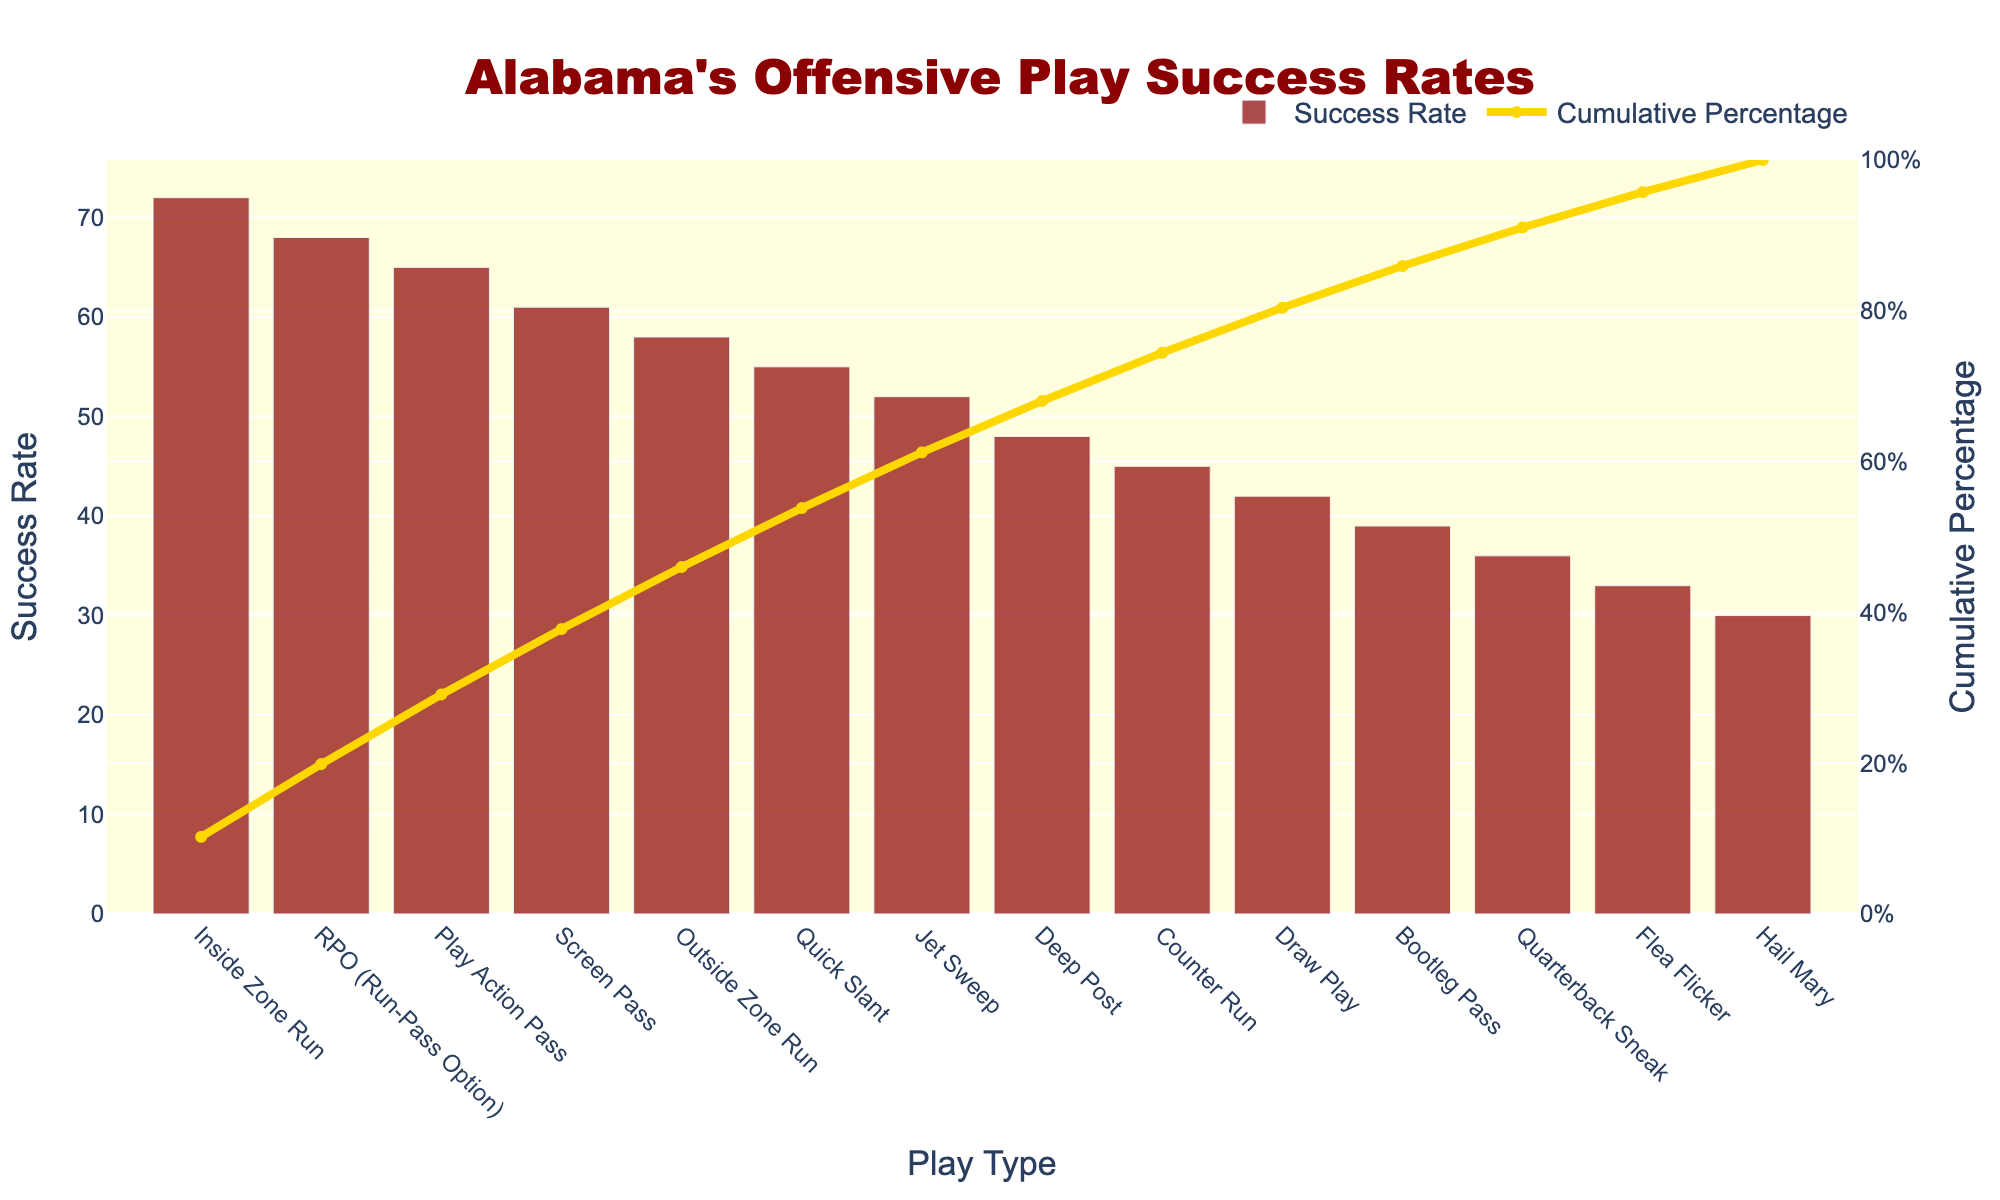How many types of offensive plays are displayed on the X-axis? There are 14 different play types listed on the X-axis. This can be counted by looking at the labels along the X-axis of the Pareto chart.
Answer: 14 What is the highest success rate for any play type? The highest success rate is indicated by the tallest bar in the bar chart portion of the Pareto chart, which corresponds to the "Inside Zone Run" with a success rate of 72%.
Answer: 72% Which play type has the lowest success rate? The lowest success rate is indicated by the shortest bar in the bar chart portion of the Pareto chart, which corresponds to the "Hail Mary" with a success rate of 30%.
Answer: Hail Mary What cumulative percentage is achieved after the first four play types? The cumulative percentage for the first four play types (Inside Zone Run, RPO, Play Action Pass, Screen Pass) can be obtained by summing their success rates and then referring to the corresponding cumulative percentage on the line chart. (72 + 68 + 65 + 61) / (72 + 68 + 65 + 61 + 58 + 55 + 52 + 48 + 45 + 42 + 39 + 36 + 33 + 30) * 100 ≈ 58.4%
Answer: 58.4% How much higher is the success rate of the "Play Action Pass" compared to "Bootleg Pass"? The difference in success rate between "Play Action Pass" and "Bootleg Pass" can be found by subtracting the success rate of the "Bootleg Pass" (39%) from the "Play Action Pass" (65%).
Answer: 26 What is the cumulative percentage of the top three play types? The cumulative percentage for the top three play types (Inside Zone Run, RPO, Play Action Pass) is given directly by the line chart, which must be read off where the top three play types end.
Answer: Around 66% Which play type achieves a 100% cumulative percentage? The final play type on the X-axis, which is "Hail Mary", will achieve a cumulative percentage of 100% since it is the cumulative total of all success rates combined.
Answer: Hail Mary What is the success rate difference between the "Quick Slant" and "Deep Post"? The success rate of "Quick Slant" is 55% and "Deep Post" is 48%. The difference is calculated as 55% - 48%.
Answer: 7 Between the "Inside Zone Run" and "Counter Run", which play type has a higher success rate, and by how much? The "Inside Zone Run" has a success rate of 72% while "Counter Run" has a success rate of 45%. The difference is 72% - 45%.
Answer: Inside Zone Run by 27 What percentage of plays contribute to the first 50% cumulative success rate? To find the percentage of play types contributing to the first 50% cumulative success rate, identify the point on the line graph where it reaches or exceeds 50%. This occurs after three play types (Inside Zone Run, RPO, Play Action Pass). Thus, 3 out of 14 play types. (3/14) * 100 ≈ 21.4%
Answer: 21.4% 